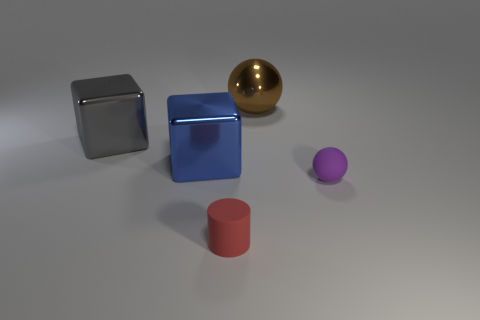Add 5 tiny red matte cylinders. How many objects exist? 10 Subtract all cubes. How many objects are left? 3 Add 3 small cyan matte cubes. How many small cyan matte cubes exist? 3 Subtract 0 green blocks. How many objects are left? 5 Subtract all red things. Subtract all red cylinders. How many objects are left? 3 Add 4 big blue objects. How many big blue objects are left? 5 